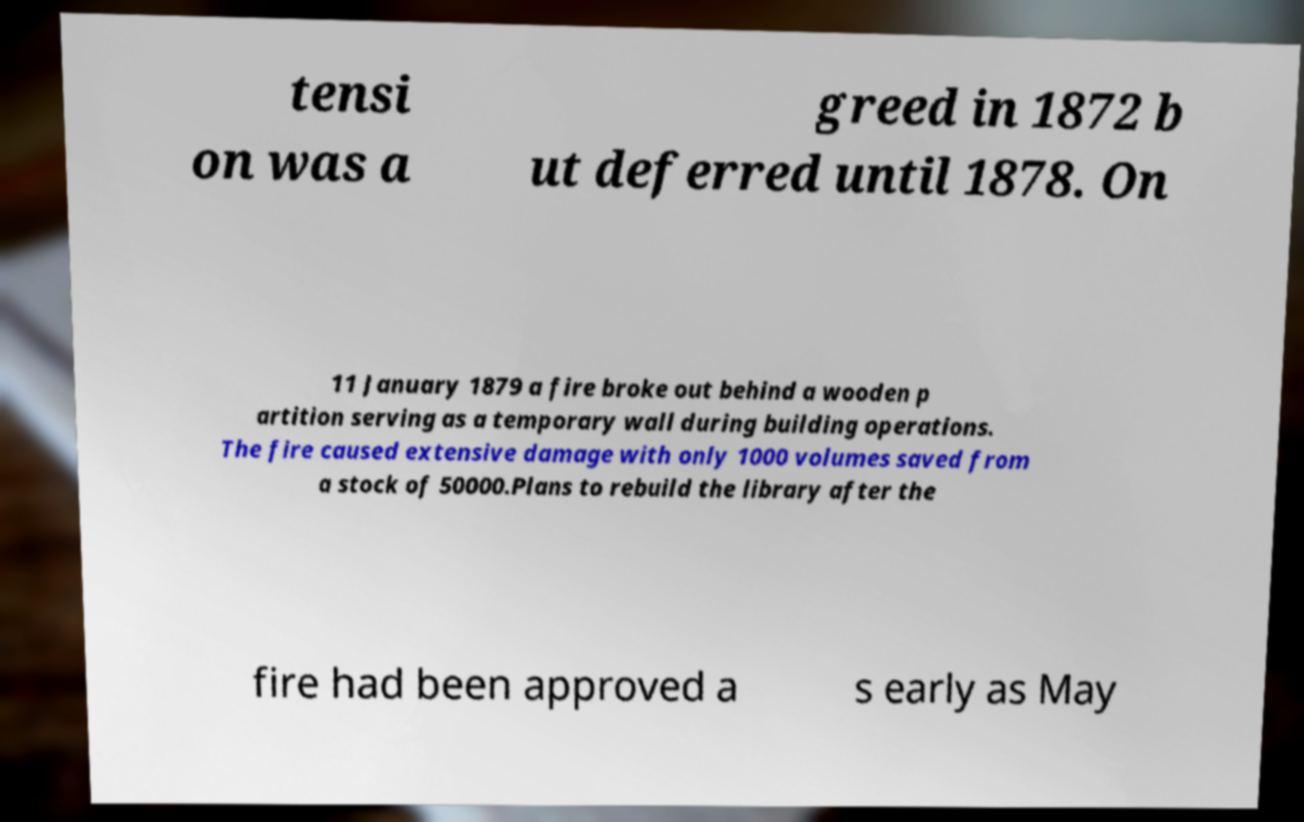Can you accurately transcribe the text from the provided image for me? tensi on was a greed in 1872 b ut deferred until 1878. On 11 January 1879 a fire broke out behind a wooden p artition serving as a temporary wall during building operations. The fire caused extensive damage with only 1000 volumes saved from a stock of 50000.Plans to rebuild the library after the fire had been approved a s early as May 